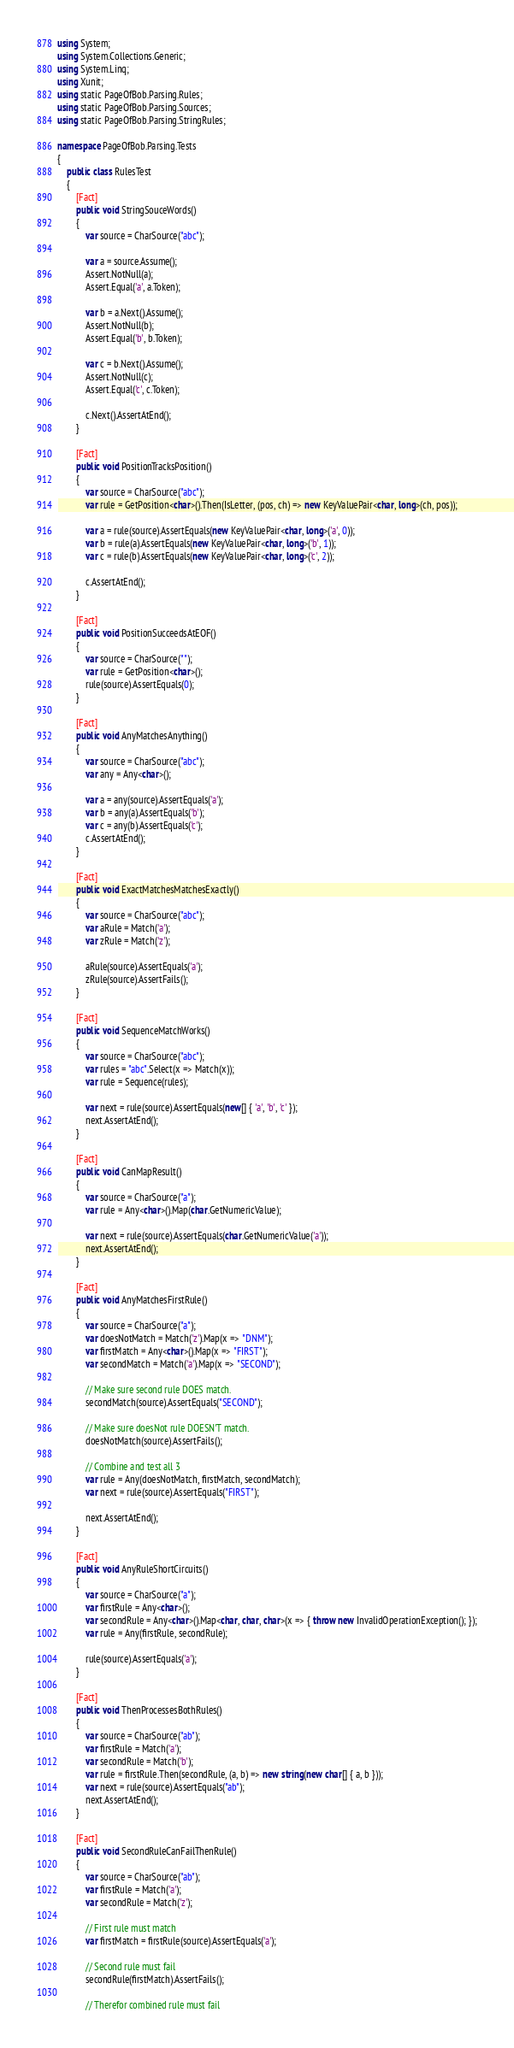<code> <loc_0><loc_0><loc_500><loc_500><_C#_>using System;
using System.Collections.Generic;
using System.Linq;
using Xunit;
using static PageOfBob.Parsing.Rules;
using static PageOfBob.Parsing.Sources;
using static PageOfBob.Parsing.StringRules;

namespace PageOfBob.Parsing.Tests
{
    public class RulesTest
    {
        [Fact]
        public void StringSouceWords()
        {
            var source = CharSource("abc");

            var a = source.Assume();
            Assert.NotNull(a);
            Assert.Equal('a', a.Token);

            var b = a.Next().Assume();
            Assert.NotNull(b);
            Assert.Equal('b', b.Token);

            var c = b.Next().Assume();
            Assert.NotNull(c);
            Assert.Equal('c', c.Token);

            c.Next().AssertAtEnd();
        }

        [Fact]
        public void PositionTracksPosition()
        {
            var source = CharSource("abc");
            var rule = GetPosition<char>().Then(IsLetter, (pos, ch) => new KeyValuePair<char, long>(ch, pos));

            var a = rule(source).AssertEquals(new KeyValuePair<char, long>('a', 0));
            var b = rule(a).AssertEquals(new KeyValuePair<char, long>('b', 1));
            var c = rule(b).AssertEquals(new KeyValuePair<char, long>('c', 2));

            c.AssertAtEnd();
        }

        [Fact]
        public void PositionSucceedsAtEOF()
        {
            var source = CharSource("");
            var rule = GetPosition<char>();
            rule(source).AssertEquals(0);
        }

        [Fact]
        public void AnyMatchesAnything()
        {
            var source = CharSource("abc");
            var any = Any<char>();

            var a = any(source).AssertEquals('a');
            var b = any(a).AssertEquals('b');
            var c = any(b).AssertEquals('c');
            c.AssertAtEnd();
        }

        [Fact]
        public void ExactMatchesMatchesExactly()
        {
            var source = CharSource("abc");
            var aRule = Match('a');
            var zRule = Match('z');

            aRule(source).AssertEquals('a');
            zRule(source).AssertFails();
        }

        [Fact]
        public void SequenceMatchWorks()
        {
            var source = CharSource("abc");
            var rules = "abc".Select(x => Match(x));
            var rule = Sequence(rules);

            var next = rule(source).AssertEquals(new[] { 'a', 'b', 'c' });
            next.AssertAtEnd();
        }

        [Fact]
        public void CanMapResult()
        {
            var source = CharSource("a");
            var rule = Any<char>().Map(char.GetNumericValue);

            var next = rule(source).AssertEquals(char.GetNumericValue('a'));
            next.AssertAtEnd();
        }

        [Fact]
        public void AnyMatchesFirstRule()
        {
            var source = CharSource("a");
            var doesNotMatch = Match('z').Map(x => "DNM");
            var firstMatch = Any<char>().Map(x => "FIRST");
            var secondMatch = Match('a').Map(x => "SECOND");

            // Make sure second rule DOES match.
            secondMatch(source).AssertEquals("SECOND");

            // Make sure doesNot rule DOESN'T match.
            doesNotMatch(source).AssertFails();

            // Combine and test all 3
            var rule = Any(doesNotMatch, firstMatch, secondMatch);
            var next = rule(source).AssertEquals("FIRST");

            next.AssertAtEnd();
        }

        [Fact]
        public void AnyRuleShortCircuits()
        {
            var source = CharSource("a");
            var firstRule = Any<char>();
            var secondRule = Any<char>().Map<char, char, char>(x => { throw new InvalidOperationException(); });
            var rule = Any(firstRule, secondRule);

            rule(source).AssertEquals('a');
        }

        [Fact]
        public void ThenProcessesBothRules()
        {
            var source = CharSource("ab");
            var firstRule = Match('a');
            var secondRule = Match('b');
            var rule = firstRule.Then(secondRule, (a, b) => new string(new char[] { a, b }));
            var next = rule(source).AssertEquals("ab");
            next.AssertAtEnd();
        }

        [Fact]
        public void SecondRuleCanFailThenRule()
        {
            var source = CharSource("ab");
            var firstRule = Match('a');
            var secondRule = Match('z');

            // First rule must match
            var firstMatch = firstRule(source).AssertEquals('a');

            // Second rule must fail
            secondRule(firstMatch).AssertFails();

            // Therefor combined rule must fail</code> 